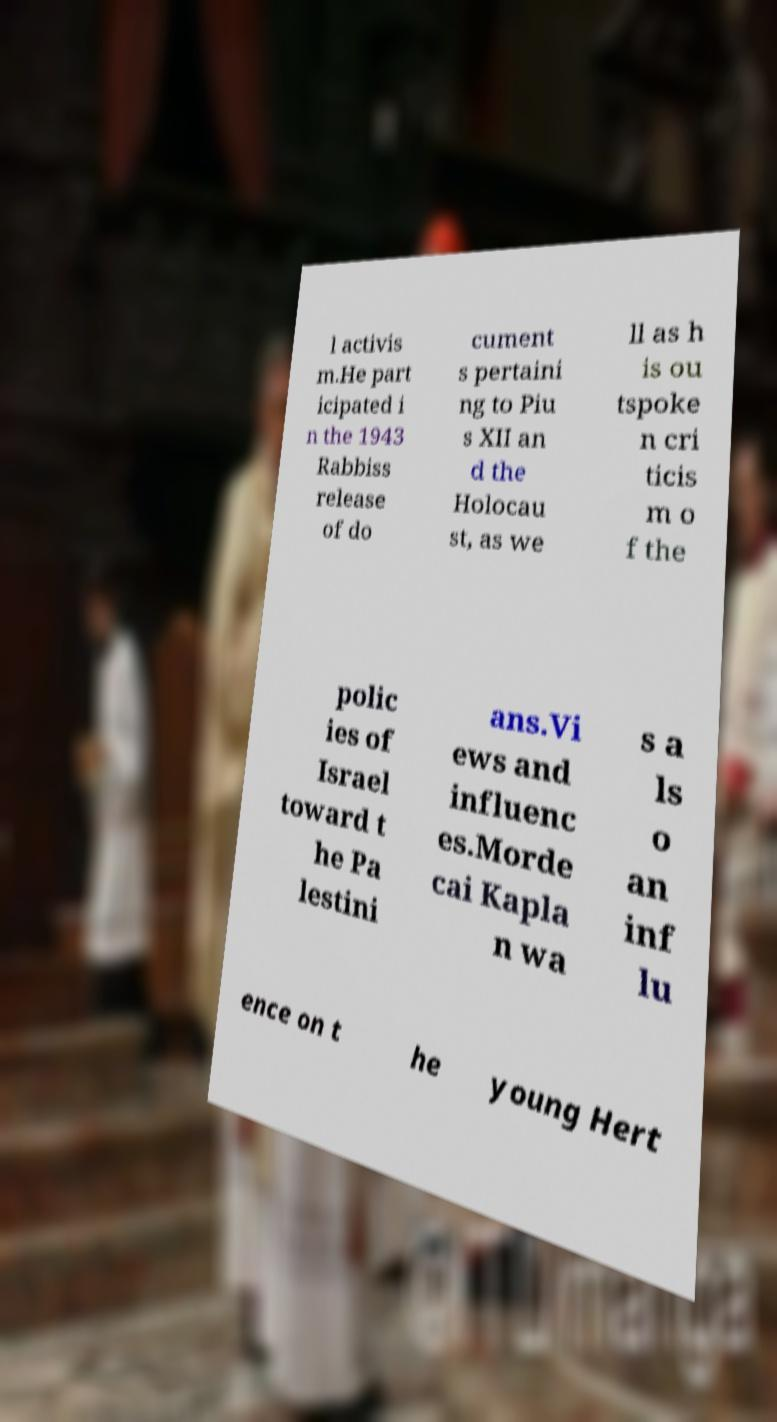There's text embedded in this image that I need extracted. Can you transcribe it verbatim? l activis m.He part icipated i n the 1943 Rabbiss release of do cument s pertaini ng to Piu s XII an d the Holocau st, as we ll as h is ou tspoke n cri ticis m o f the polic ies of Israel toward t he Pa lestini ans.Vi ews and influenc es.Morde cai Kapla n wa s a ls o an inf lu ence on t he young Hert 